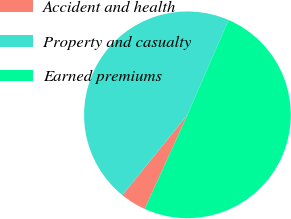<chart> <loc_0><loc_0><loc_500><loc_500><pie_chart><fcel>Accident and health<fcel>Property and casualty<fcel>Earned premiums<nl><fcel>4.05%<fcel>45.68%<fcel>50.27%<nl></chart> 